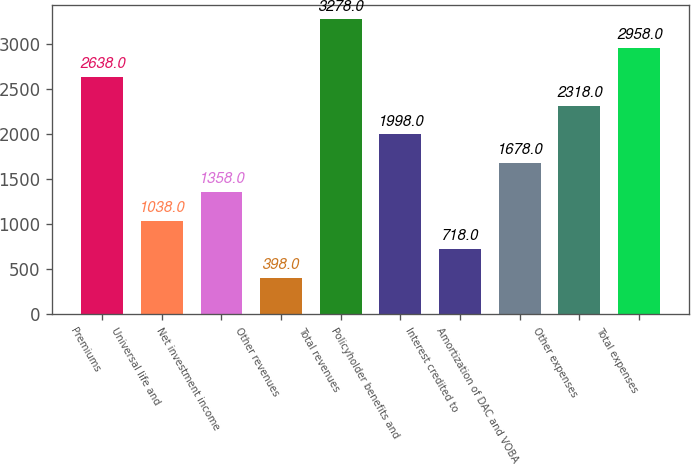Convert chart to OTSL. <chart><loc_0><loc_0><loc_500><loc_500><bar_chart><fcel>Premiums<fcel>Universal life and<fcel>Net investment income<fcel>Other revenues<fcel>Total revenues<fcel>Policyholder benefits and<fcel>Interest credited to<fcel>Amortization of DAC and VOBA<fcel>Other expenses<fcel>Total expenses<nl><fcel>2638<fcel>1038<fcel>1358<fcel>398<fcel>3278<fcel>1998<fcel>718<fcel>1678<fcel>2318<fcel>2958<nl></chart> 